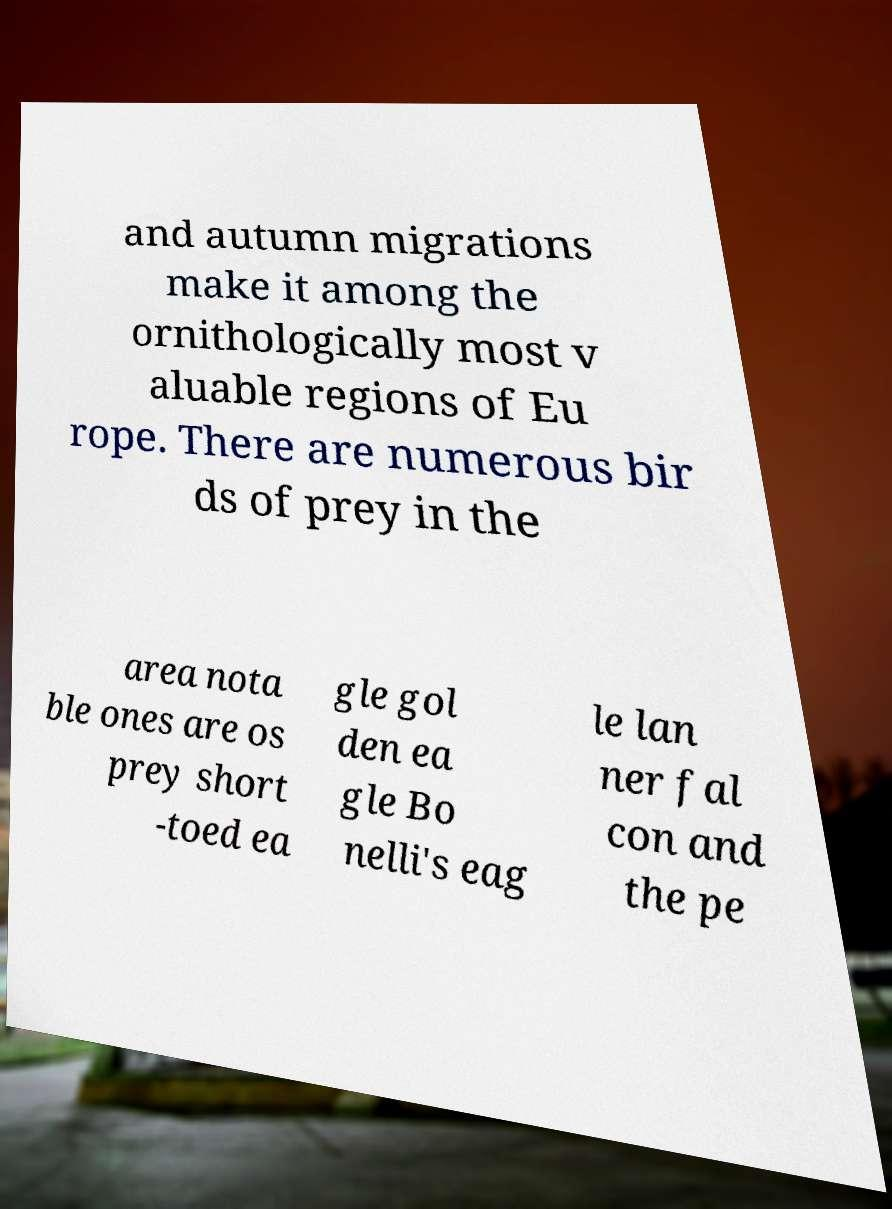Please read and relay the text visible in this image. What does it say? and autumn migrations make it among the ornithologically most v aluable regions of Eu rope. There are numerous bir ds of prey in the area nota ble ones are os prey short -toed ea gle gol den ea gle Bo nelli's eag le lan ner fal con and the pe 